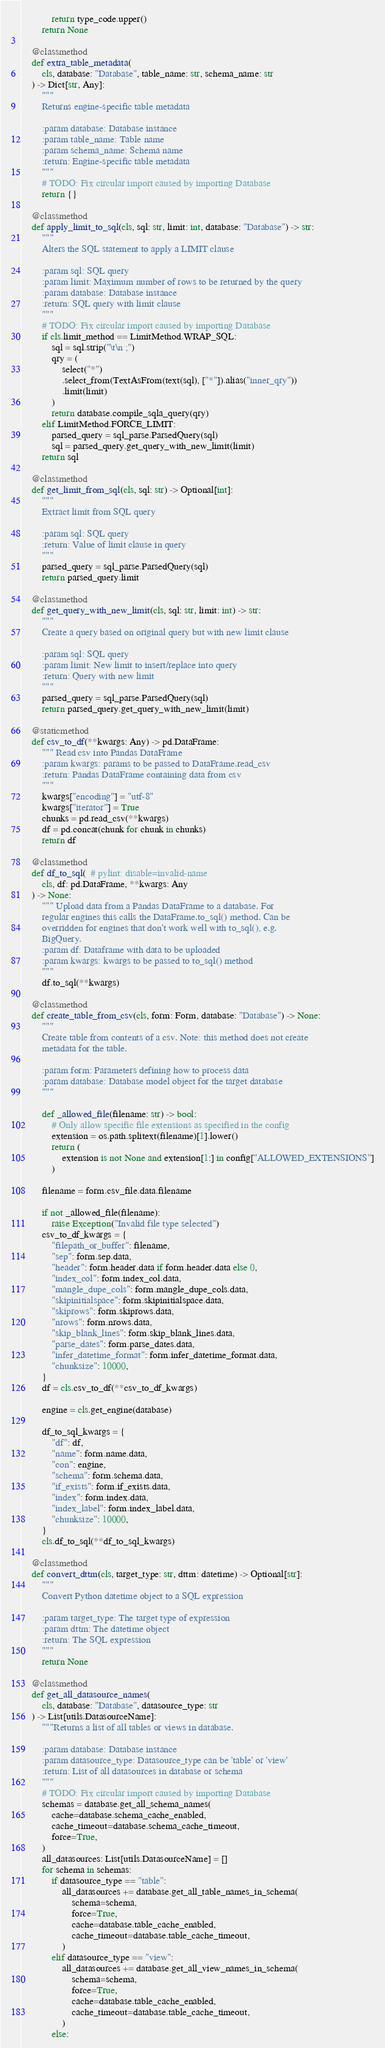<code> <loc_0><loc_0><loc_500><loc_500><_Python_>            return type_code.upper()
        return None

    @classmethod
    def extra_table_metadata(
        cls, database: "Database", table_name: str, schema_name: str
    ) -> Dict[str, Any]:
        """
        Returns engine-specific table metadata

        :param database: Database instance
        :param table_name: Table name
        :param schema_name: Schema name
        :return: Engine-specific table metadata
        """
        # TODO: Fix circular import caused by importing Database
        return {}

    @classmethod
    def apply_limit_to_sql(cls, sql: str, limit: int, database: "Database") -> str:
        """
        Alters the SQL statement to apply a LIMIT clause

        :param sql: SQL query
        :param limit: Maximum number of rows to be returned by the query
        :param database: Database instance
        :return: SQL query with limit clause
        """
        # TODO: Fix circular import caused by importing Database
        if cls.limit_method == LimitMethod.WRAP_SQL:
            sql = sql.strip("\t\n ;")
            qry = (
                select("*")
                .select_from(TextAsFrom(text(sql), ["*"]).alias("inner_qry"))
                .limit(limit)
            )
            return database.compile_sqla_query(qry)
        elif LimitMethod.FORCE_LIMIT:
            parsed_query = sql_parse.ParsedQuery(sql)
            sql = parsed_query.get_query_with_new_limit(limit)
        return sql

    @classmethod
    def get_limit_from_sql(cls, sql: str) -> Optional[int]:
        """
        Extract limit from SQL query

        :param sql: SQL query
        :return: Value of limit clause in query
        """
        parsed_query = sql_parse.ParsedQuery(sql)
        return parsed_query.limit

    @classmethod
    def get_query_with_new_limit(cls, sql: str, limit: int) -> str:
        """
        Create a query based on original query but with new limit clause

        :param sql: SQL query
        :param limit: New limit to insert/replace into query
        :return: Query with new limit
        """
        parsed_query = sql_parse.ParsedQuery(sql)
        return parsed_query.get_query_with_new_limit(limit)

    @staticmethod
    def csv_to_df(**kwargs: Any) -> pd.DataFrame:
        """ Read csv into Pandas DataFrame
        :param kwargs: params to be passed to DataFrame.read_csv
        :return: Pandas DataFrame containing data from csv
        """
        kwargs["encoding"] = "utf-8"
        kwargs["iterator"] = True
        chunks = pd.read_csv(**kwargs)
        df = pd.concat(chunk for chunk in chunks)
        return df

    @classmethod
    def df_to_sql(  # pylint: disable=invalid-name
        cls, df: pd.DataFrame, **kwargs: Any
    ) -> None:
        """ Upload data from a Pandas DataFrame to a database. For
        regular engines this calls the DataFrame.to_sql() method. Can be
        overridden for engines that don't work well with to_sql(), e.g.
        BigQuery.
        :param df: Dataframe with data to be uploaded
        :param kwargs: kwargs to be passed to to_sql() method
        """
        df.to_sql(**kwargs)

    @classmethod
    def create_table_from_csv(cls, form: Form, database: "Database") -> None:
        """
        Create table from contents of a csv. Note: this method does not create
        metadata for the table.

        :param form: Parameters defining how to process data
        :param database: Database model object for the target database
        """

        def _allowed_file(filename: str) -> bool:
            # Only allow specific file extensions as specified in the config
            extension = os.path.splitext(filename)[1].lower()
            return (
                extension is not None and extension[1:] in config["ALLOWED_EXTENSIONS"]
            )

        filename = form.csv_file.data.filename

        if not _allowed_file(filename):
            raise Exception("Invalid file type selected")
        csv_to_df_kwargs = {
            "filepath_or_buffer": filename,
            "sep": form.sep.data,
            "header": form.header.data if form.header.data else 0,
            "index_col": form.index_col.data,
            "mangle_dupe_cols": form.mangle_dupe_cols.data,
            "skipinitialspace": form.skipinitialspace.data,
            "skiprows": form.skiprows.data,
            "nrows": form.nrows.data,
            "skip_blank_lines": form.skip_blank_lines.data,
            "parse_dates": form.parse_dates.data,
            "infer_datetime_format": form.infer_datetime_format.data,
            "chunksize": 10000,
        }
        df = cls.csv_to_df(**csv_to_df_kwargs)

        engine = cls.get_engine(database)

        df_to_sql_kwargs = {
            "df": df,
            "name": form.name.data,
            "con": engine,
            "schema": form.schema.data,
            "if_exists": form.if_exists.data,
            "index": form.index.data,
            "index_label": form.index_label.data,
            "chunksize": 10000,
        }
        cls.df_to_sql(**df_to_sql_kwargs)

    @classmethod
    def convert_dttm(cls, target_type: str, dttm: datetime) -> Optional[str]:
        """
        Convert Python datetime object to a SQL expression

        :param target_type: The target type of expression
        :param dttm: The datetime object
        :return: The SQL expression
        """
        return None

    @classmethod
    def get_all_datasource_names(
        cls, database: "Database", datasource_type: str
    ) -> List[utils.DatasourceName]:
        """Returns a list of all tables or views in database.

        :param database: Database instance
        :param datasource_type: Datasource_type can be 'table' or 'view'
        :return: List of all datasources in database or schema
        """
        # TODO: Fix circular import caused by importing Database
        schemas = database.get_all_schema_names(
            cache=database.schema_cache_enabled,
            cache_timeout=database.schema_cache_timeout,
            force=True,
        )
        all_datasources: List[utils.DatasourceName] = []
        for schema in schemas:
            if datasource_type == "table":
                all_datasources += database.get_all_table_names_in_schema(
                    schema=schema,
                    force=True,
                    cache=database.table_cache_enabled,
                    cache_timeout=database.table_cache_timeout,
                )
            elif datasource_type == "view":
                all_datasources += database.get_all_view_names_in_schema(
                    schema=schema,
                    force=True,
                    cache=database.table_cache_enabled,
                    cache_timeout=database.table_cache_timeout,
                )
            else:</code> 